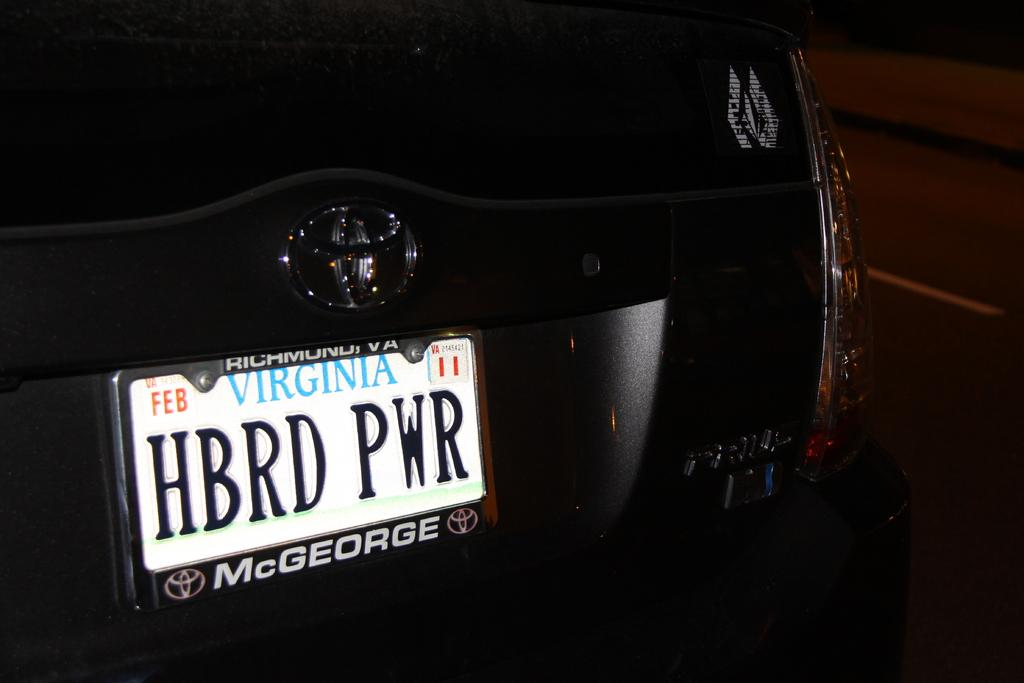<image>
Present a compact description of the photo's key features. Virginia license plate which says HBRD PWR on it. 